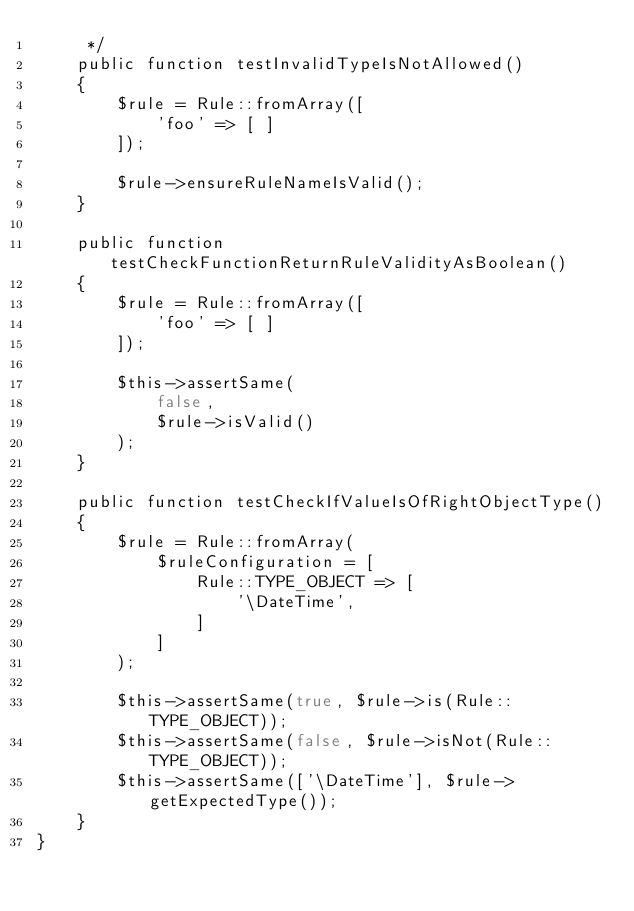<code> <loc_0><loc_0><loc_500><loc_500><_PHP_>     */
    public function testInvalidTypeIsNotAllowed()
    {
        $rule = Rule::fromArray([
            'foo' => [ ]
        ]);

        $rule->ensureRuleNameIsValid();
    }

    public function testCheckFunctionReturnRuleValidityAsBoolean()
    {
        $rule = Rule::fromArray([
            'foo' => [ ]
        ]);

        $this->assertSame(
            false,
            $rule->isValid()
        );
    }

    public function testCheckIfValueIsOfRightObjectType()
    {
        $rule = Rule::fromArray(
            $ruleConfiguration = [
                Rule::TYPE_OBJECT => [
                    '\DateTime',
                ]
            ]
        );

        $this->assertSame(true, $rule->is(Rule::TYPE_OBJECT));
        $this->assertSame(false, $rule->isNot(Rule::TYPE_OBJECT));
        $this->assertSame(['\DateTime'], $rule->getExpectedType());
    }
}
</code> 